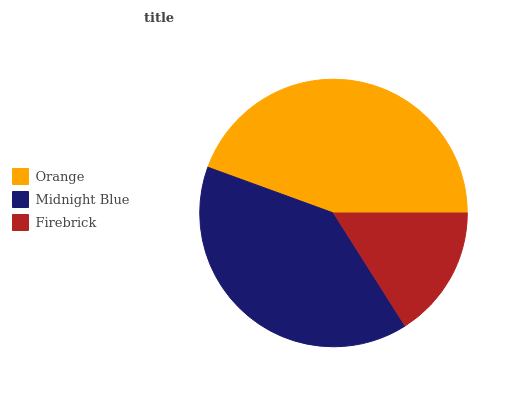Is Firebrick the minimum?
Answer yes or no. Yes. Is Orange the maximum?
Answer yes or no. Yes. Is Midnight Blue the minimum?
Answer yes or no. No. Is Midnight Blue the maximum?
Answer yes or no. No. Is Orange greater than Midnight Blue?
Answer yes or no. Yes. Is Midnight Blue less than Orange?
Answer yes or no. Yes. Is Midnight Blue greater than Orange?
Answer yes or no. No. Is Orange less than Midnight Blue?
Answer yes or no. No. Is Midnight Blue the high median?
Answer yes or no. Yes. Is Midnight Blue the low median?
Answer yes or no. Yes. Is Orange the high median?
Answer yes or no. No. Is Firebrick the low median?
Answer yes or no. No. 